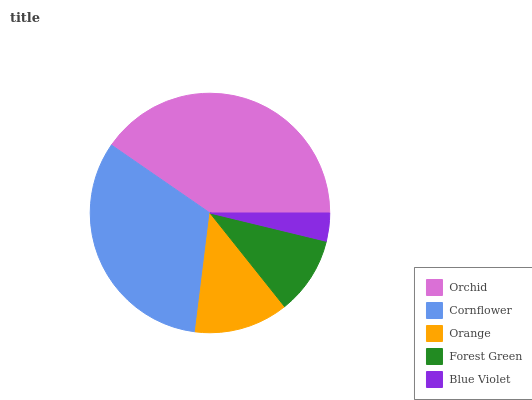Is Blue Violet the minimum?
Answer yes or no. Yes. Is Orchid the maximum?
Answer yes or no. Yes. Is Cornflower the minimum?
Answer yes or no. No. Is Cornflower the maximum?
Answer yes or no. No. Is Orchid greater than Cornflower?
Answer yes or no. Yes. Is Cornflower less than Orchid?
Answer yes or no. Yes. Is Cornflower greater than Orchid?
Answer yes or no. No. Is Orchid less than Cornflower?
Answer yes or no. No. Is Orange the high median?
Answer yes or no. Yes. Is Orange the low median?
Answer yes or no. Yes. Is Orchid the high median?
Answer yes or no. No. Is Forest Green the low median?
Answer yes or no. No. 